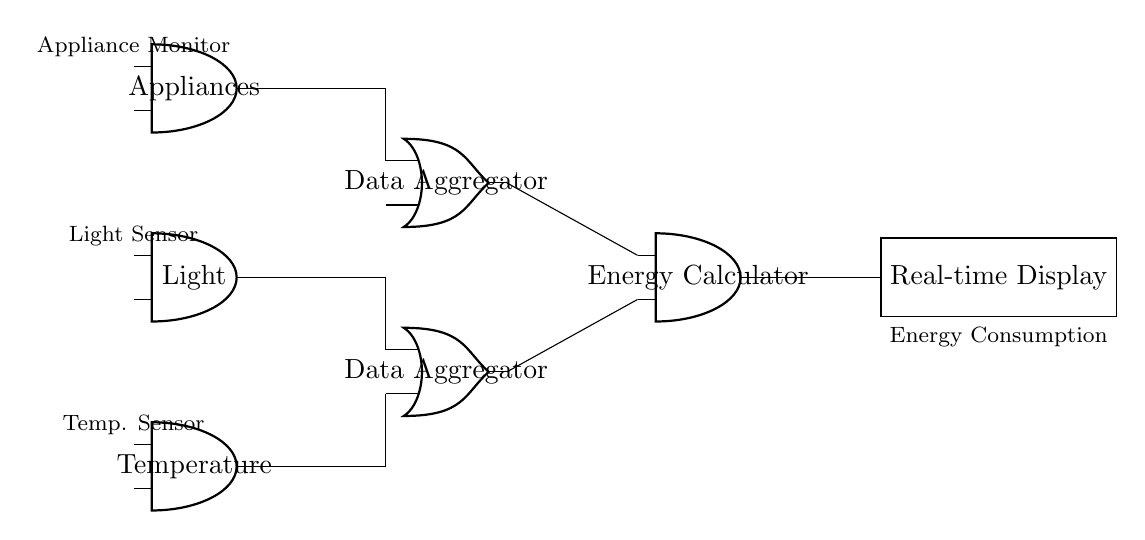What type of circuit is this? This circuit is a logic gate circuit, as indicated by the presence of AND and OR gates, which are used to process input signals to produce output.
Answer: Logic gate How many AND gates are present in this circuit? There are four AND gates shown in the circuit: three at the input (Temperature, Light, Appliances) and one for Energy Calculation.
Answer: Four What is the purpose of the OR gates in this circuit? The OR gates act as data aggregators for combining input signals from the sensor outputs before sending them to the Energy Calculator.
Answer: Data aggregation Which components are used as inputs to the Energy Calculator? The inputs to the Energy Calculator come from the outputs of the two OR gates, which aggregate data from the various sensors.
Answer: OR gate outputs What is displayed at the final output of this circuit? The final output of this circuit is the "Real-time Display," which shows the calculated energy consumption based on the processed data.
Answer: Real-time Display What role does the Temperature Sensor play in this circuit? The Temperature Sensor is an input component providing data related to temperature, which is then processed by the logic gates to track energy consumption.
Answer: Input data How does the data flow from the sensors to the display? Data flows from the Temperature, Light, and Appliance sensors to OR gates that aggregate the signals, then to the AND gate for calculation, and finally to the Real-time Display showing the result.
Answer: Sensor to OR to AND to Display 